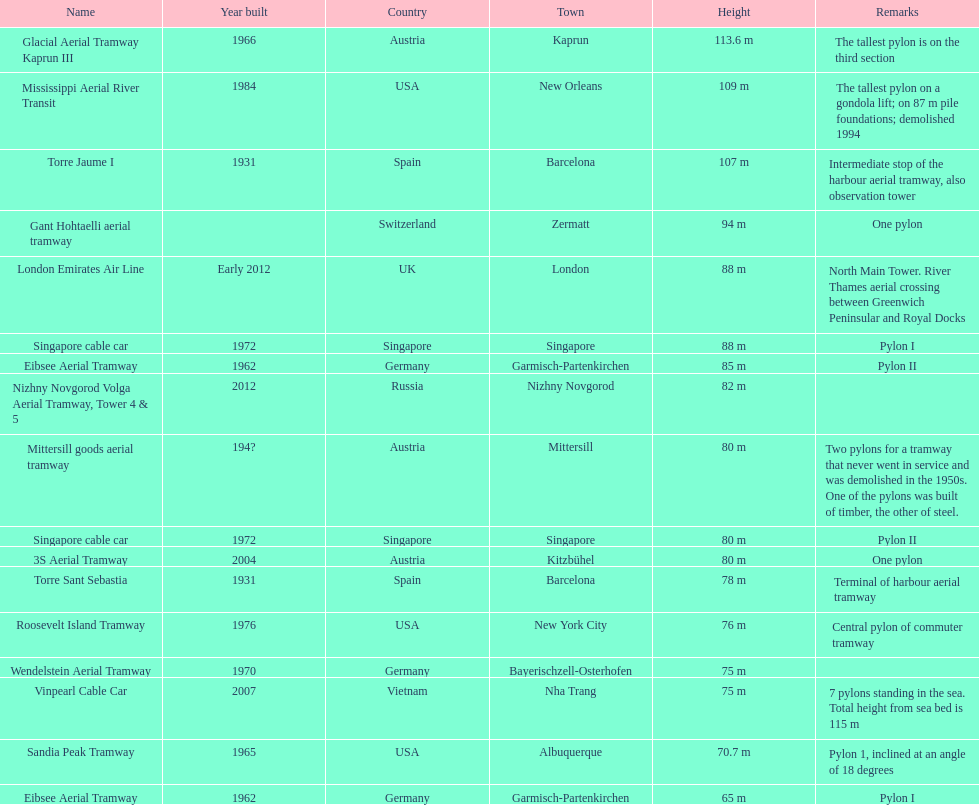How many pylons are in austria? 3. 